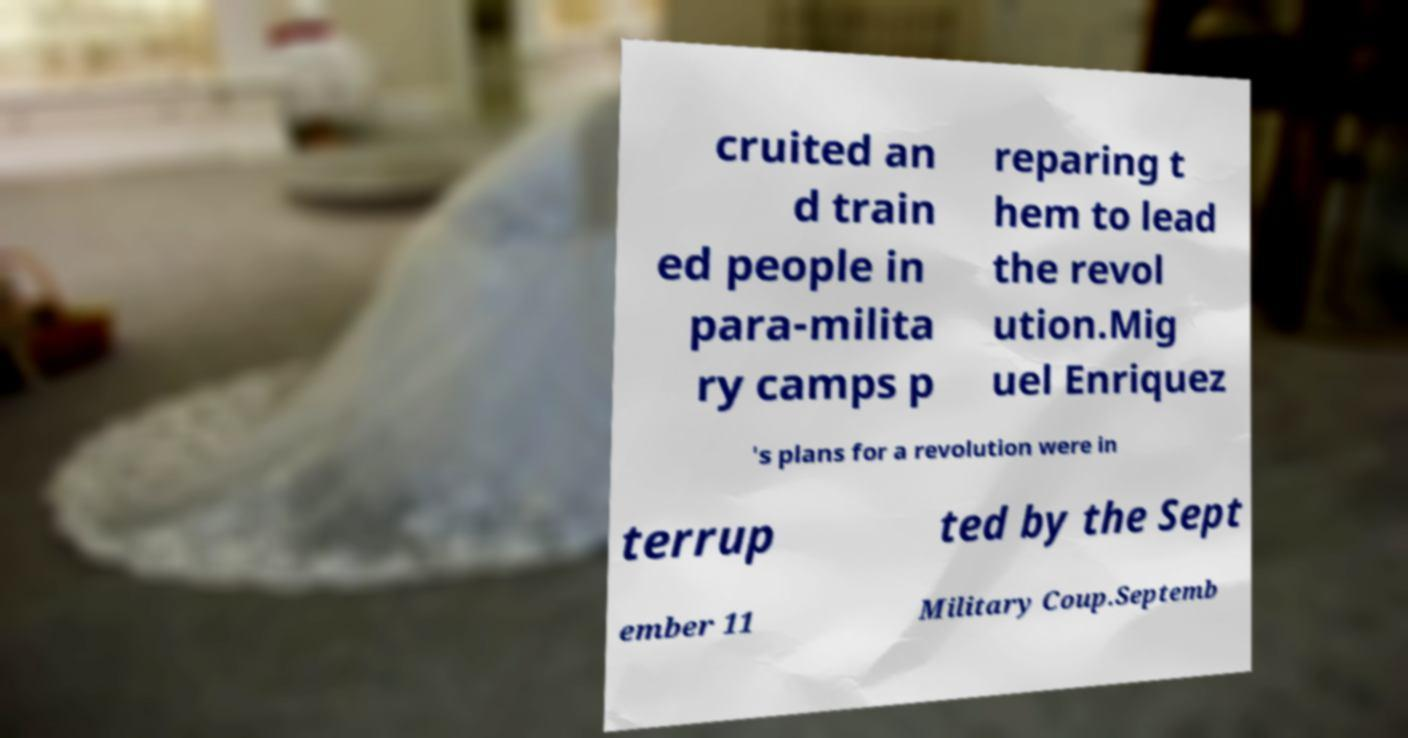There's text embedded in this image that I need extracted. Can you transcribe it verbatim? cruited an d train ed people in para-milita ry camps p reparing t hem to lead the revol ution.Mig uel Enriquez 's plans for a revolution were in terrup ted by the Sept ember 11 Military Coup.Septemb 